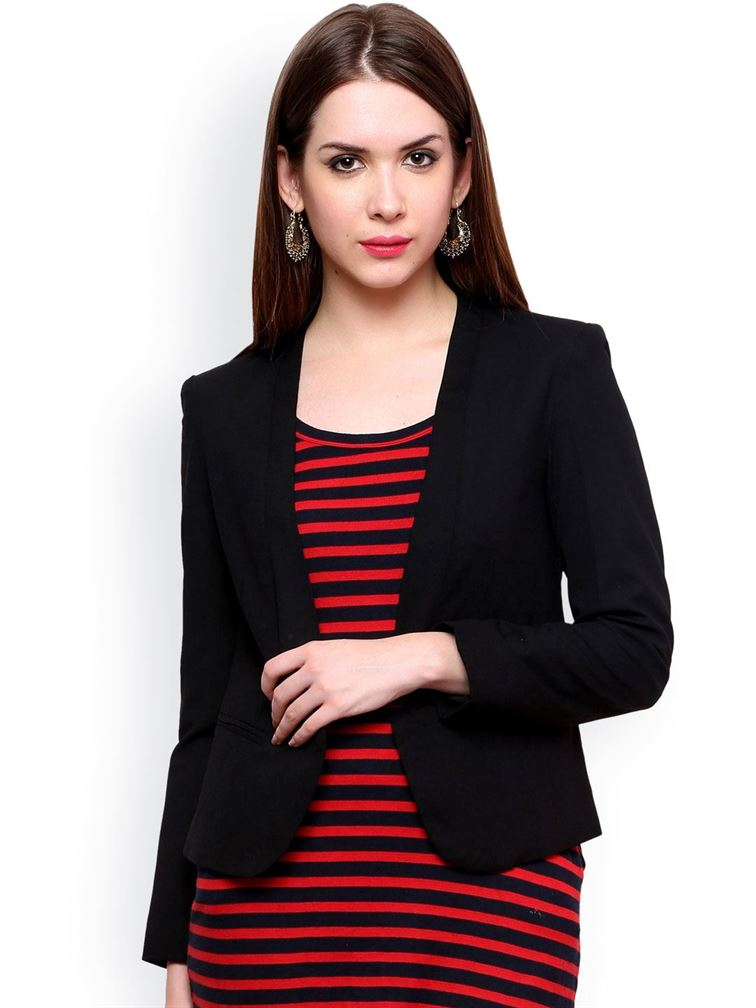If these earrings had a story, what would it be? These earrings could tell the tale of a woman who traveled the world, collecting unique pieces of jewelry from different cultures. These particular earrings, with their intricate design and elegant finish, could be a treasured find from a bustling market in a historical Mediterranean city. They remind the wearer of the vibrant colors, lively sounds, and rich history she experienced during her travels. Perhaps she bought them from a skilled artisan who shared with her the ancient techniques used to craft them, making the earrings not only a beautiful accessory but a piece of living history. If the woman in the image had to describe her day so far, what do you think she would say? She might describe her day with a sense of accomplishment and a touch of fatigue. 'Today has been incredibly productive,' she could say. 'I started my morning with a meeting that went better than expected—even managed to secure that new deal we've been working on. Afterward, I had a quick lunch with a colleague, followed by back-to-back appointments with clients. Though it's been hectic, I'm ending the day on a high note, ready to wind down and reflect on today's successes while planning for tomorrow's challenges.' What might be the significance of the red and black color combination in her outfit? The red and black color combination in her outfit could be significant for several reasons. Red is often associated with energy, passion, and confidence, which might reflect her bold and assertive personality or her active role in professional settings. Black, on the other hand, symbolizes elegance, sophistication, and authority. Together, these colors create a powerful visual impact, suggesting a blend of dynamism and professionalism. This combination can communicate that she is both approachable and in control, making it an excellent choice for business or social environments where making a lasting impression is important. 